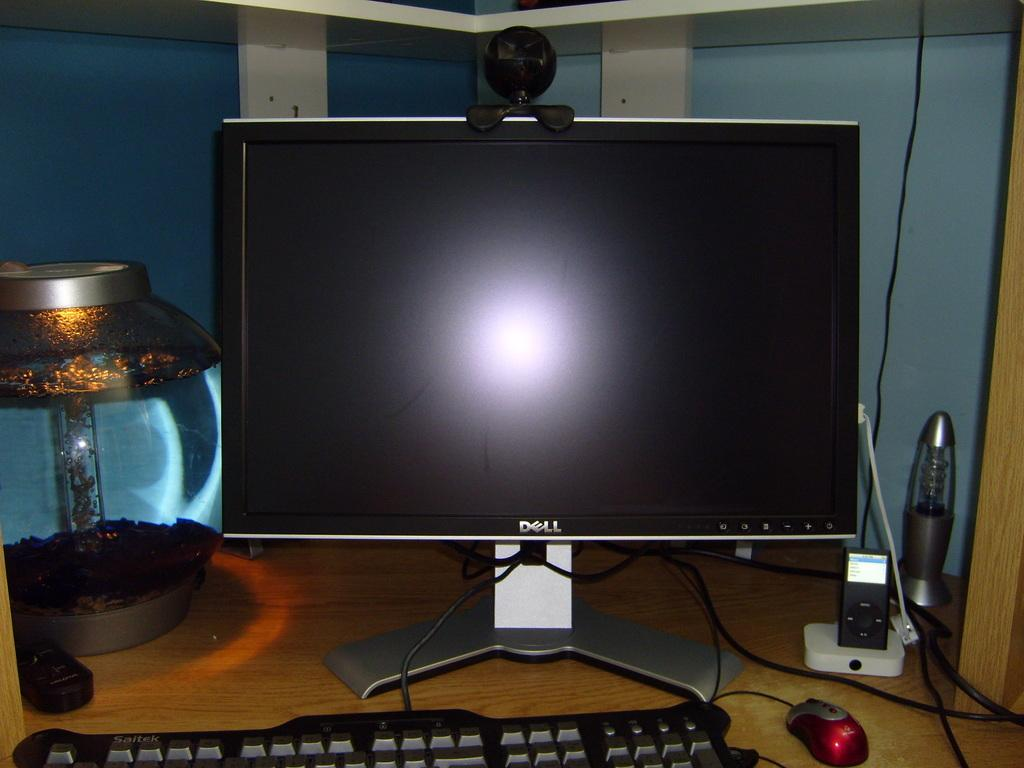<image>
Provide a brief description of the given image. A Dell monitor that is currently off with a keyboard in front of it. 